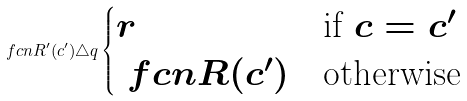<formula> <loc_0><loc_0><loc_500><loc_500>\ f c n { R ^ { \prime } } ( c ^ { \prime } ) \triangle q \begin{cases} r & \text {if } c = c ^ { \prime } \\ \ f c n { R } ( c ^ { \prime } ) & \text {otherwise} \end{cases}</formula> 